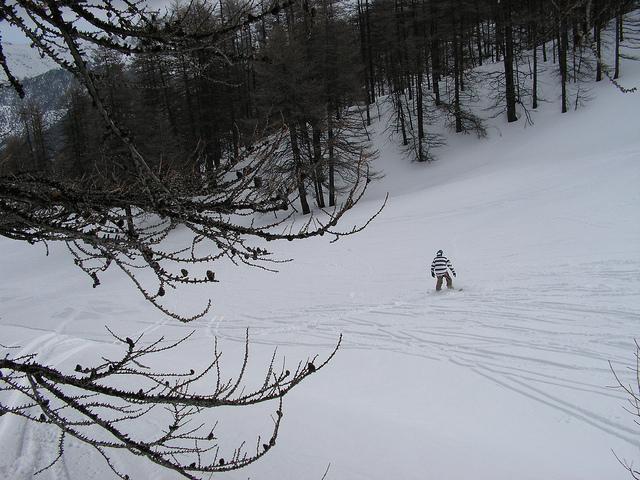What are the little bumps on the tree branches?
Choose the correct response, then elucidate: 'Answer: answer
Rationale: rationale.'
Options: Insects, leaves, seed cones, hives. Answer: seed cones.
Rationale: They hold unborn trees. 